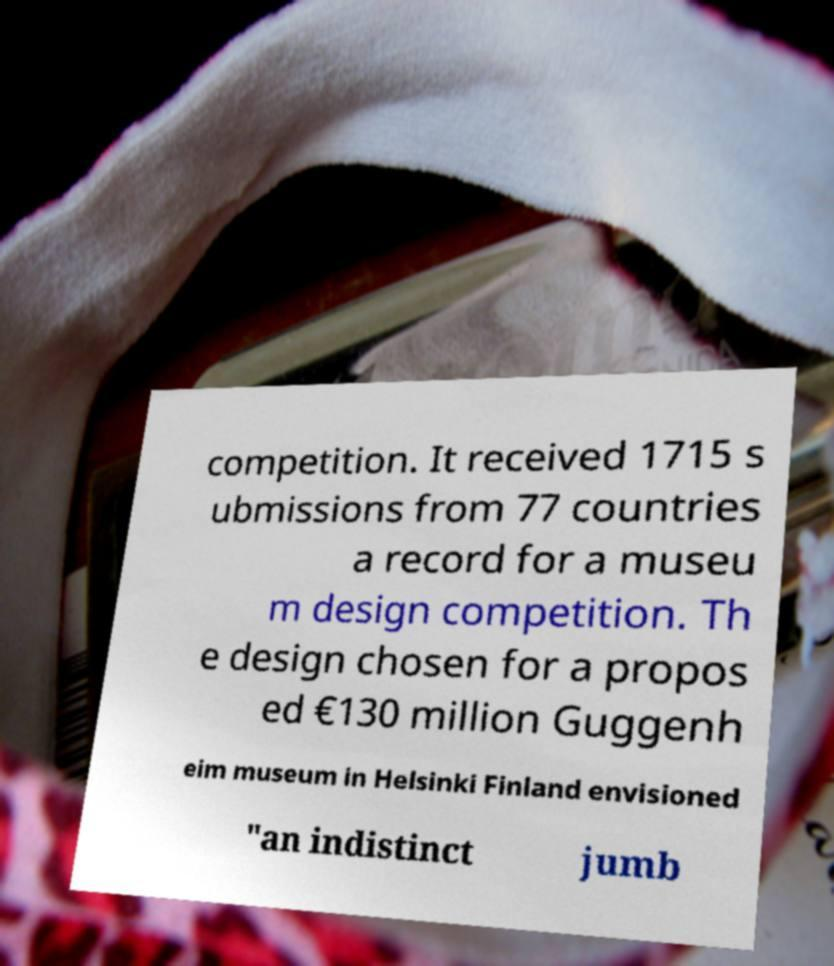Please read and relay the text visible in this image. What does it say? competition. It received 1715 s ubmissions from 77 countries a record for a museu m design competition. Th e design chosen for a propos ed €130 million Guggenh eim museum in Helsinki Finland envisioned "an indistinct jumb 